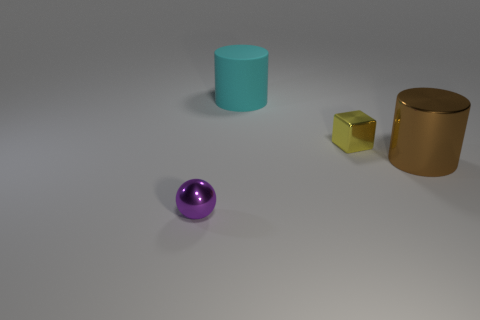Add 1 big red metal balls. How many objects exist? 5 Subtract all balls. How many objects are left? 3 Subtract all cyan cylinders. Subtract all purple metal balls. How many objects are left? 2 Add 4 cyan cylinders. How many cyan cylinders are left? 5 Add 4 purple shiny cylinders. How many purple shiny cylinders exist? 4 Subtract 1 brown cylinders. How many objects are left? 3 